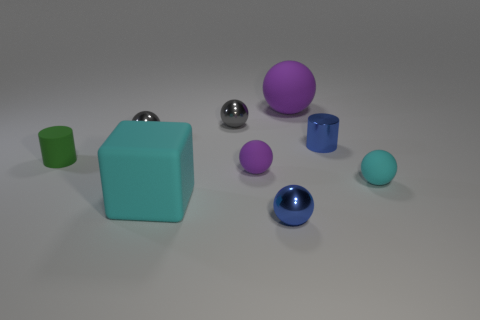Subtract all large matte balls. How many balls are left? 5 Subtract all cyan cylinders. How many gray spheres are left? 2 Add 2 small green matte things. How many small green matte things exist? 3 Subtract all purple balls. How many balls are left? 4 Subtract 1 blue spheres. How many objects are left? 8 Subtract all blocks. How many objects are left? 8 Subtract 1 cylinders. How many cylinders are left? 1 Subtract all cyan cylinders. Subtract all brown blocks. How many cylinders are left? 2 Subtract all small matte spheres. Subtract all matte things. How many objects are left? 2 Add 2 small metal things. How many small metal things are left? 6 